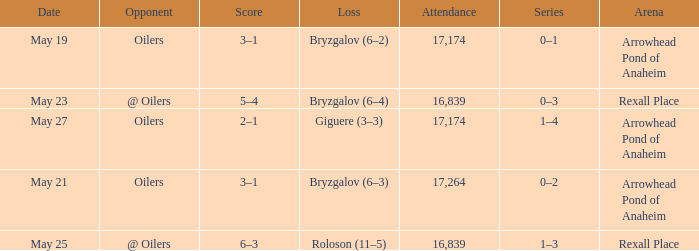Which Attendance has an Arena of arrowhead pond of anaheim, and a Loss of giguere (3–3)? 17174.0. 